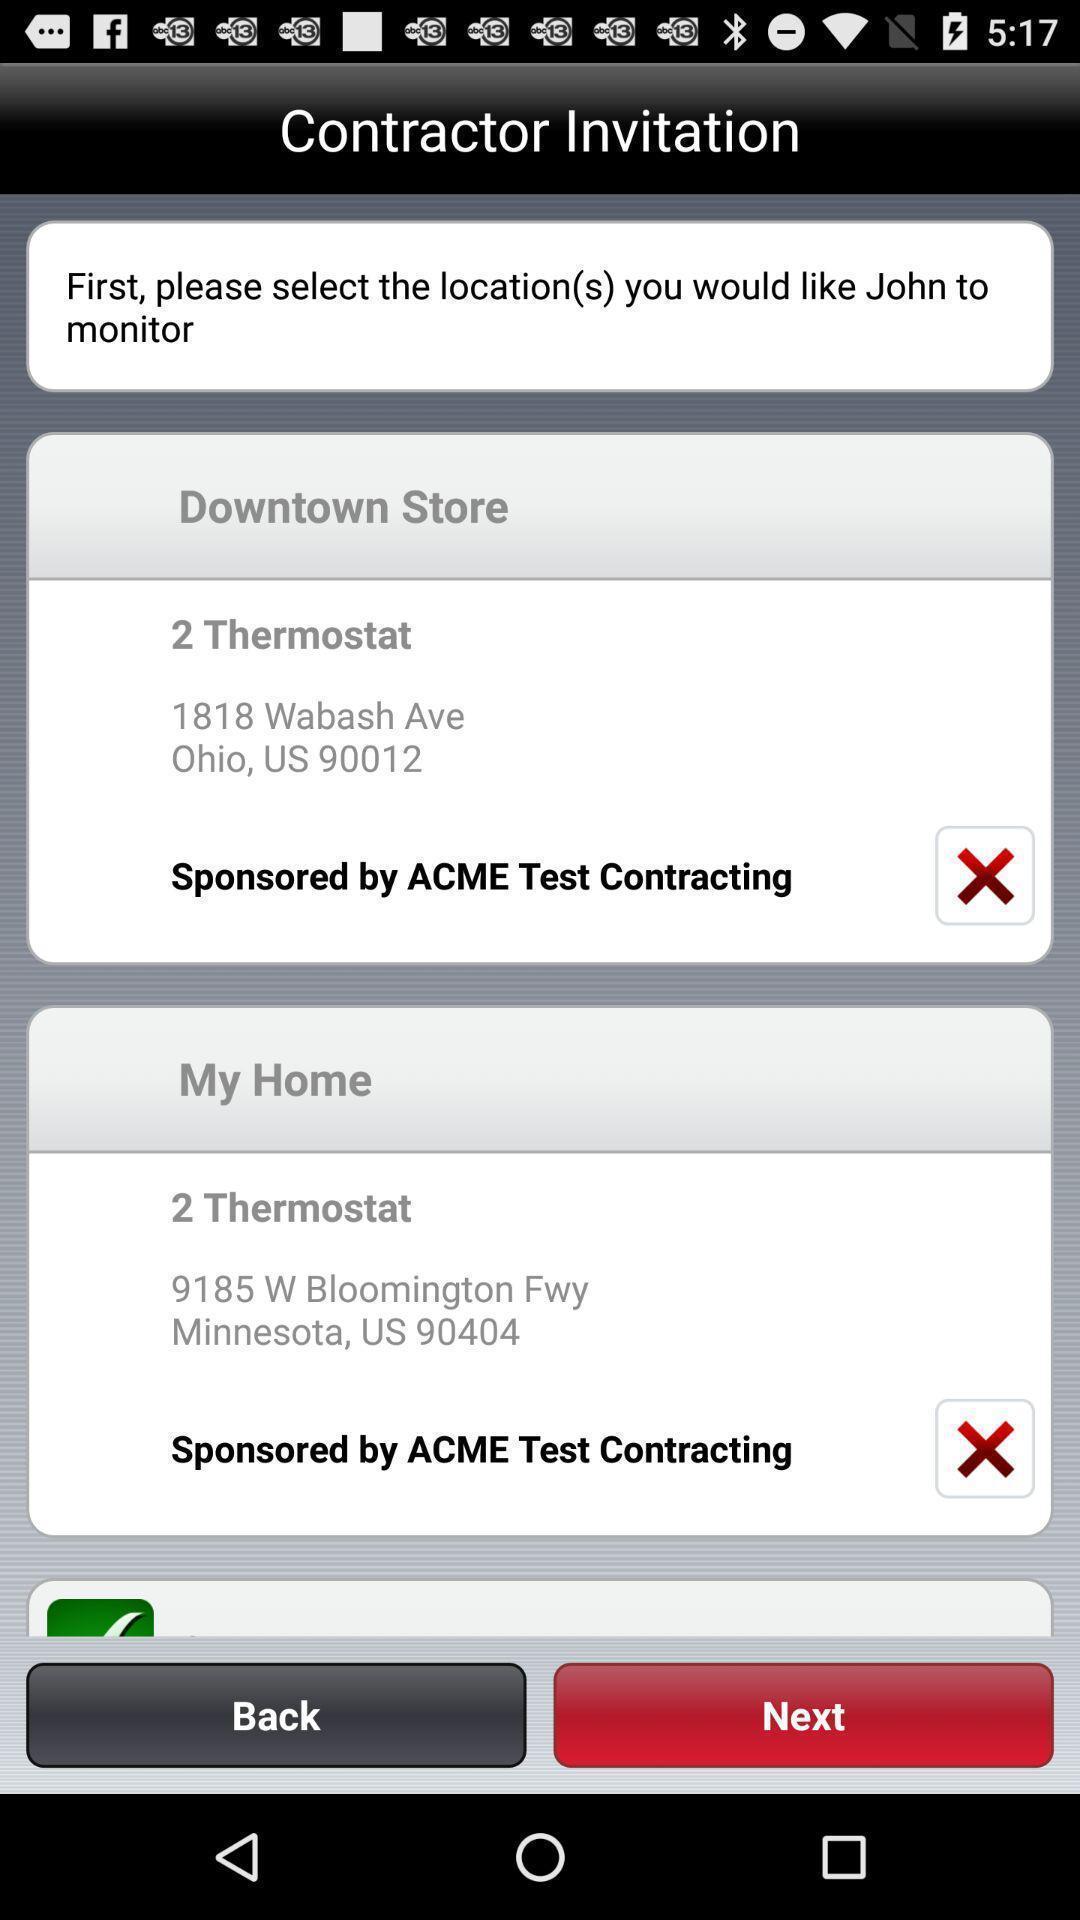What is the overall content of this screenshot? Window displaying about heating and cooling systems. 